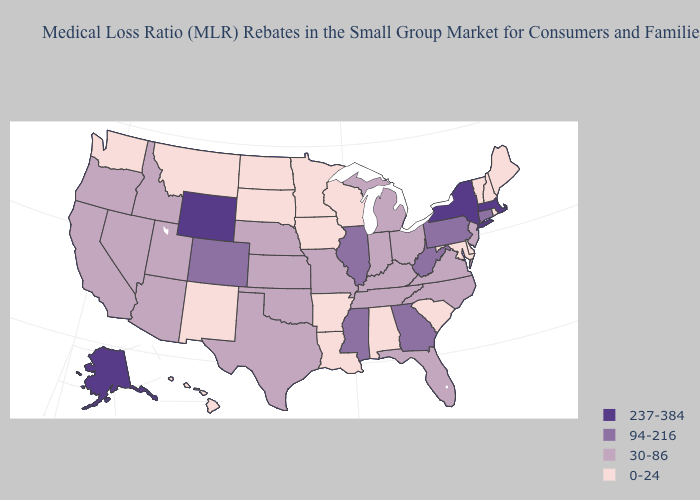Among the states that border Maine , which have the highest value?
Short answer required. New Hampshire. Which states hav the highest value in the MidWest?
Be succinct. Illinois. Name the states that have a value in the range 94-216?
Write a very short answer. Colorado, Connecticut, Georgia, Illinois, Mississippi, Pennsylvania, West Virginia. Name the states that have a value in the range 0-24?
Be succinct. Alabama, Arkansas, Delaware, Hawaii, Iowa, Louisiana, Maine, Maryland, Minnesota, Montana, New Hampshire, New Mexico, North Dakota, Rhode Island, South Carolina, South Dakota, Vermont, Washington, Wisconsin. Among the states that border Iowa , which have the highest value?
Be succinct. Illinois. Does Arkansas have the lowest value in the USA?
Give a very brief answer. Yes. Which states hav the highest value in the South?
Quick response, please. Georgia, Mississippi, West Virginia. Among the states that border Wisconsin , which have the highest value?
Quick response, please. Illinois. Name the states that have a value in the range 94-216?
Answer briefly. Colorado, Connecticut, Georgia, Illinois, Mississippi, Pennsylvania, West Virginia. Name the states that have a value in the range 0-24?
Concise answer only. Alabama, Arkansas, Delaware, Hawaii, Iowa, Louisiana, Maine, Maryland, Minnesota, Montana, New Hampshire, New Mexico, North Dakota, Rhode Island, South Carolina, South Dakota, Vermont, Washington, Wisconsin. Does Kentucky have the highest value in the USA?
Be succinct. No. Does the map have missing data?
Keep it brief. No. Among the states that border New Hampshire , which have the lowest value?
Keep it brief. Maine, Vermont. What is the value of Texas?
Concise answer only. 30-86. What is the lowest value in the West?
Quick response, please. 0-24. 